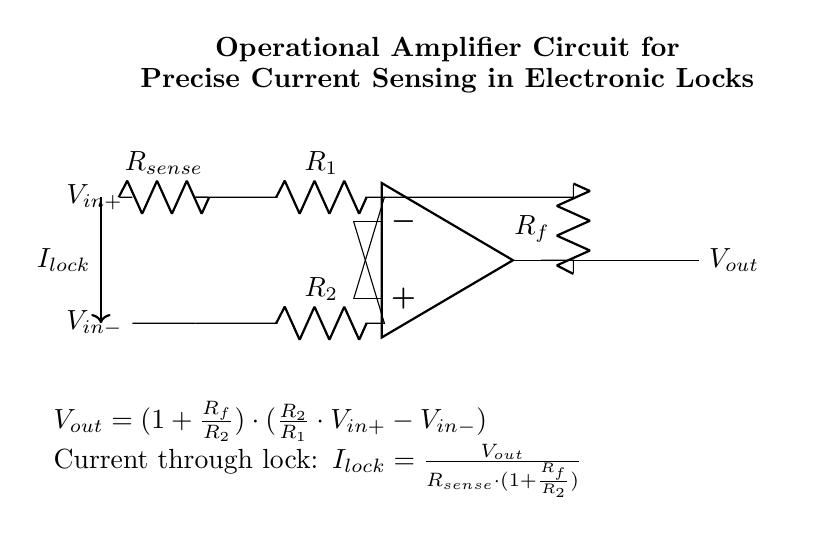What is the function of the operational amplifier in this circuit? The operational amplifier amplifies the difference between the input voltages, resulting in a scaled output voltage that corresponds to the current flowing through the lock.
Answer: Amplification What are the resistors labeled in the circuit? The resistors in the circuit are labeled as R1, R2, and Rf. R1 and R2 are part of the input configuration, while Rf is the feedback resistor.
Answer: R1, R2, Rf How is the current through the lock calculated? The current through the lock is calculated using the formula I_lock = V_out / (R_sense * (1 + Rf/R2)), where V_out is the output voltage and R_sense is the sense resistor value.
Answer: I_lock = V_out / (R_sense * (1 + Rf/R2)) What do the labels V_in+ and V_in- represent? The labels V_in+ and V_in- represent the positive and negative input voltages to the operational amplifier, respectively, which are used to determine the output based on their difference.
Answer: Positive and Negative inputs What does the feedback resistor Rf control in the circuit? The feedback resistor Rf controls the gain of the operational amplifier circuit by determining how much of the output voltage is fed back to the inverting input, affecting the output voltage accordingly.
Answer: Gain control What is the role of the current sense resistor R_sense? The current sense resistor R_sense allows for the measurement of the current flowing through the electronic lock by developing a voltage drop proportional to that current, which can then be amplified by the operational amplifier.
Answer: Current measurement What does V_out represent in the circuit? V_out represents the output voltage of the operational amplifier, which is a scaled version of the input voltage difference and provides information about the current flowing through the lock.
Answer: Output voltage 